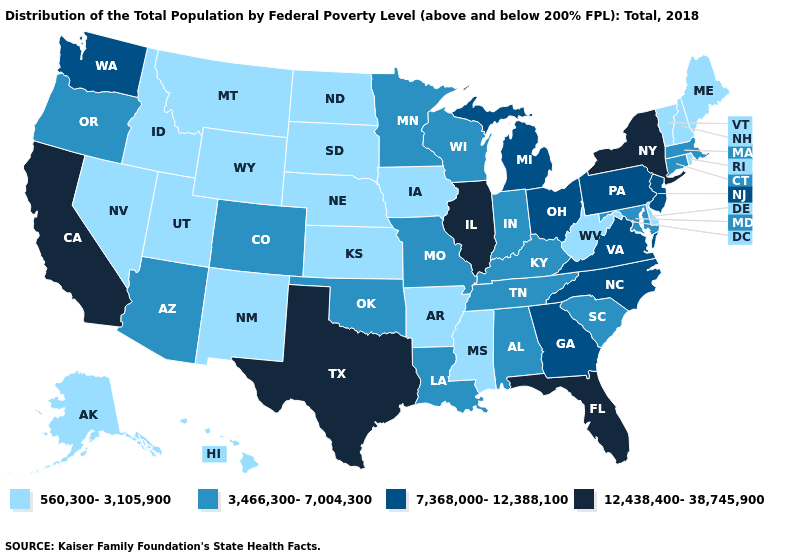Among the states that border Pennsylvania , which have the highest value?
Quick response, please. New York. What is the value of Colorado?
Quick response, please. 3,466,300-7,004,300. Does Minnesota have the lowest value in the USA?
Keep it brief. No. Does Wisconsin have the lowest value in the MidWest?
Short answer required. No. Name the states that have a value in the range 3,466,300-7,004,300?
Concise answer only. Alabama, Arizona, Colorado, Connecticut, Indiana, Kentucky, Louisiana, Maryland, Massachusetts, Minnesota, Missouri, Oklahoma, Oregon, South Carolina, Tennessee, Wisconsin. Among the states that border Iowa , which have the highest value?
Short answer required. Illinois. What is the lowest value in states that border California?
Be succinct. 560,300-3,105,900. Does the map have missing data?
Be succinct. No. Among the states that border West Virginia , does Ohio have the lowest value?
Be succinct. No. Among the states that border Vermont , which have the highest value?
Be succinct. New York. Does Maine have the lowest value in the Northeast?
Answer briefly. Yes. What is the lowest value in the MidWest?
Short answer required. 560,300-3,105,900. What is the value of Ohio?
Be succinct. 7,368,000-12,388,100. Name the states that have a value in the range 3,466,300-7,004,300?
Answer briefly. Alabama, Arizona, Colorado, Connecticut, Indiana, Kentucky, Louisiana, Maryland, Massachusetts, Minnesota, Missouri, Oklahoma, Oregon, South Carolina, Tennessee, Wisconsin. What is the value of Minnesota?
Answer briefly. 3,466,300-7,004,300. 